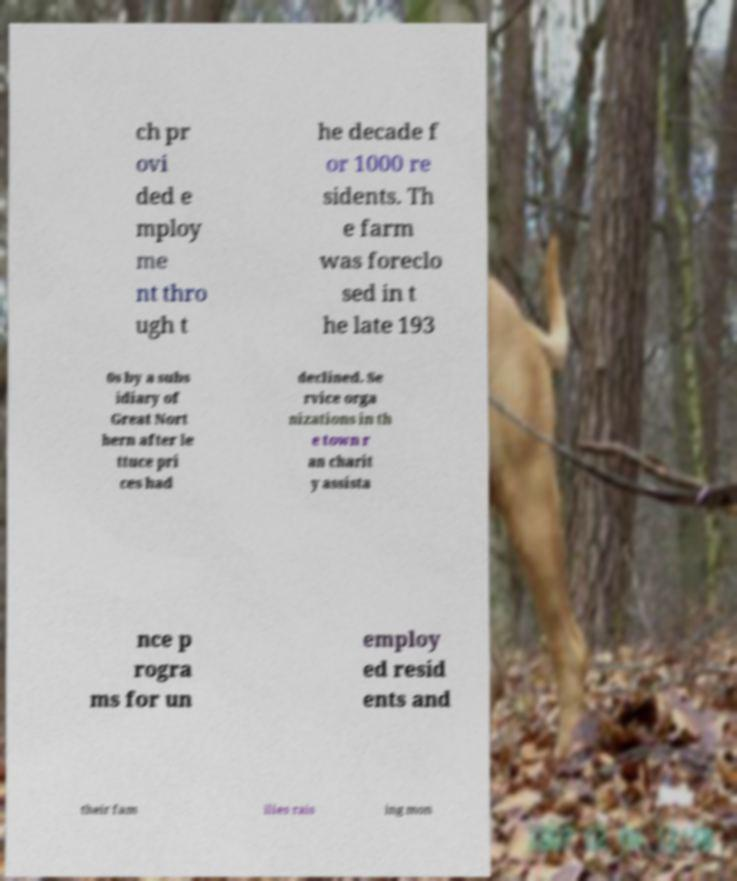I need the written content from this picture converted into text. Can you do that? ch pr ovi ded e mploy me nt thro ugh t he decade f or 1000 re sidents. Th e farm was foreclo sed in t he late 193 0s by a subs idiary of Great Nort hern after le ttuce pri ces had declined. Se rvice orga nizations in th e town r an charit y assista nce p rogra ms for un employ ed resid ents and their fam ilies rais ing mon 